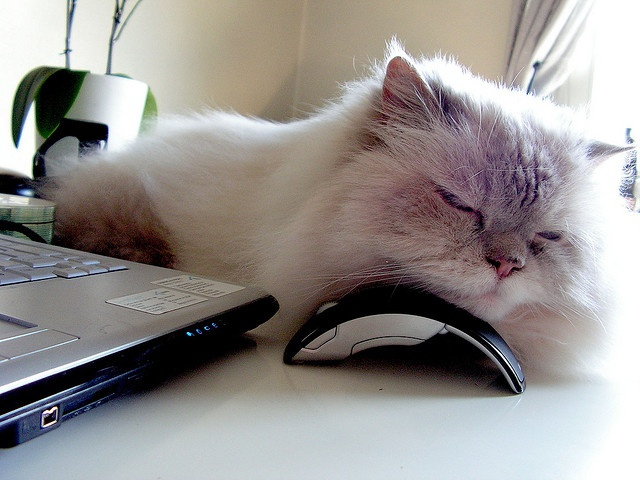Describe the objects in this image and their specific colors. I can see cat in white, gray, darkgray, and lightgray tones, laptop in white, gray, and black tones, mouse in white, black, and gray tones, and potted plant in white, black, darkgray, and gray tones in this image. 